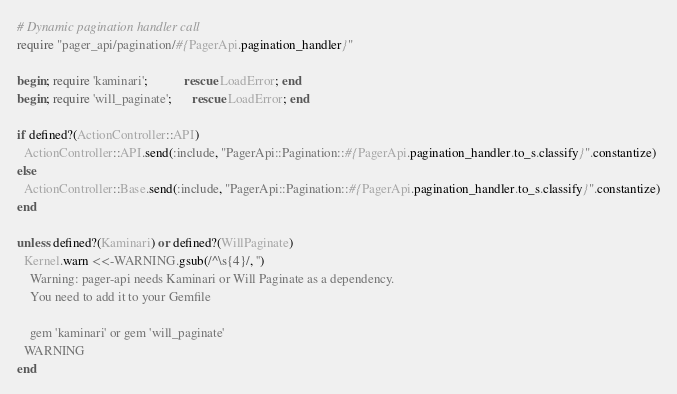Convert code to text. <code><loc_0><loc_0><loc_500><loc_500><_Ruby_># Dynamic pagination handler call
require "pager_api/pagination/#{PagerApi.pagination_handler}"

begin; require 'kaminari';           rescue LoadError; end
begin; require 'will_paginate';      rescue LoadError; end

if defined?(ActionController::API)
  ActionController::API.send(:include, "PagerApi::Pagination::#{PagerApi.pagination_handler.to_s.classify}".constantize)
else
  ActionController::Base.send(:include, "PagerApi::Pagination::#{PagerApi.pagination_handler.to_s.classify}".constantize)
end

unless defined?(Kaminari) or defined?(WillPaginate)
  Kernel.warn <<-WARNING.gsub(/^\s{4}/, '')
    Warning: pager-api needs Kaminari or Will Paginate as a dependency.
    You need to add it to your Gemfile

    gem 'kaminari' or gem 'will_paginate'
  WARNING
end
</code> 